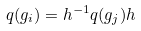Convert formula to latex. <formula><loc_0><loc_0><loc_500><loc_500>q ( g _ { i } ) = h ^ { - 1 } q ( g _ { j } ) h</formula> 